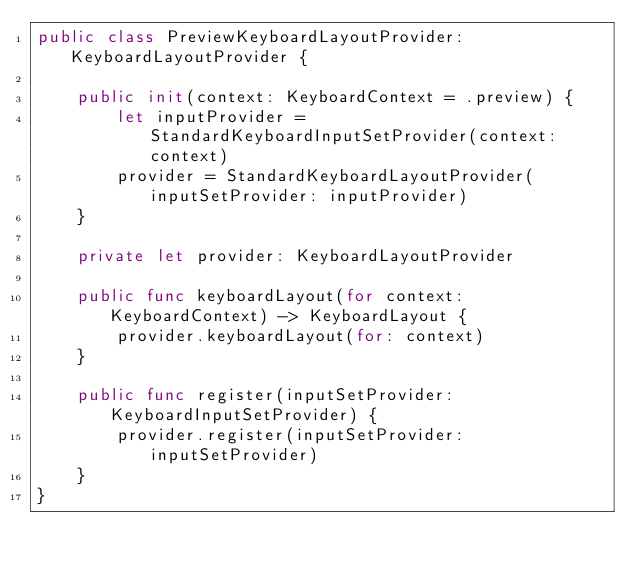Convert code to text. <code><loc_0><loc_0><loc_500><loc_500><_Swift_>public class PreviewKeyboardLayoutProvider: KeyboardLayoutProvider {
    
    public init(context: KeyboardContext = .preview) {
        let inputProvider = StandardKeyboardInputSetProvider(context: context)
        provider = StandardKeyboardLayoutProvider(inputSetProvider: inputProvider)
    }
    
    private let provider: KeyboardLayoutProvider
    
    public func keyboardLayout(for context: KeyboardContext) -> KeyboardLayout {
        provider.keyboardLayout(for: context)
    }
    
    public func register(inputSetProvider: KeyboardInputSetProvider) {
        provider.register(inputSetProvider: inputSetProvider)
    }
}
</code> 